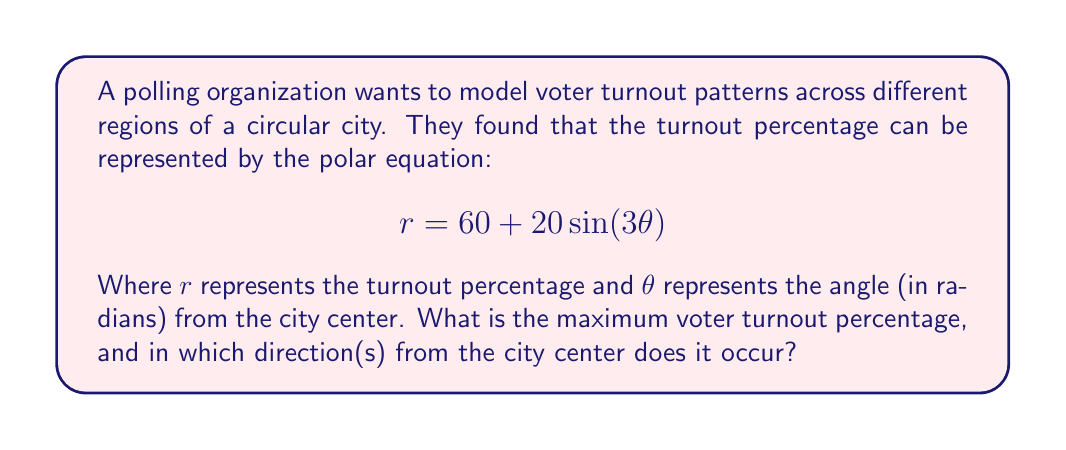Could you help me with this problem? To solve this problem, we need to follow these steps:

1) The maximum voter turnout will occur when $\sin(3\theta)$ reaches its maximum value of 1.

2) The general form of the equation is $r = a + b\sin(n\theta)$, where:
   $a = 60$ (the average turnout)
   $b = 20$ (the amplitude of the variation)
   $n = 3$ (the frequency of the variation)

3) The maximum value of $r$ will be when $\sin(3\theta) = 1$:

   $$r_{max} = 60 + 20(1) = 80$$

4) To find the directions, we need to solve:

   $$\sin(3\theta) = 1$$

5) This occurs when:

   $$3\theta = \frac{\pi}{2}, \frac{5\pi}{2}, \frac{9\pi}{2}, ...$$

6) Solving for $\theta$:

   $$\theta = \frac{\pi}{6}, \frac{5\pi}{6}, \frac{3\pi}{2}, ...$$

7) Converting to degrees:

   $$\theta = 30°, 150°, 270°$$

8) These angles represent the directions NNE, SSE, and W from the city center.

[asy]
import graph;
size(200);
real r(real t) {return 60+20*sin(3*t);}
draw(polargraph(r,0,2pi,operator ..),blue);
draw(circle((0,0),80),red+dashed);
label("80%",(-56.57,-56.57),NE,red);
draw((0,0)--(69.28,40),green,Arrow);
draw((0,0)--(-69.28,40),green,Arrow);
draw((0,0)--(0,-80),green,Arrow);
label("30°",(20,11.5),E);
label("150°",(-20,11.5),W);
label("270°",(-5,-40),W);
[/asy]
Answer: The maximum voter turnout is 80%, occurring in three directions from the city center: 30° (NNE), 150° (SSE), and 270° (W). 